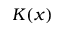Convert formula to latex. <formula><loc_0><loc_0><loc_500><loc_500>K ( x )</formula> 